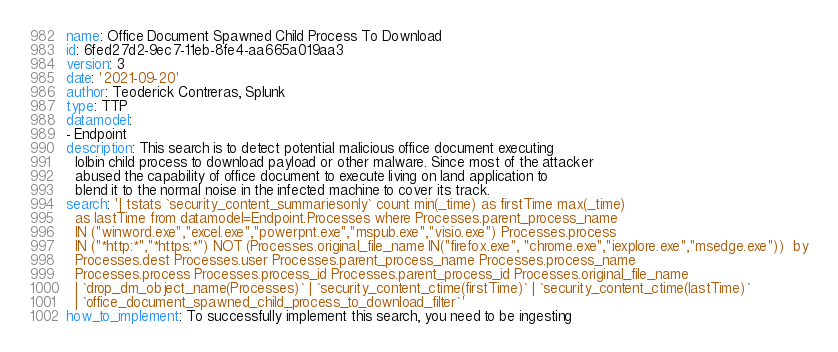Convert code to text. <code><loc_0><loc_0><loc_500><loc_500><_YAML_>name: Office Document Spawned Child Process To Download
id: 6fed27d2-9ec7-11eb-8fe4-aa665a019aa3
version: 3
date: '2021-09-20'
author: Teoderick Contreras, Splunk
type: TTP
datamodel:
- Endpoint
description: This search is to detect potential malicious office document executing
  lolbin child process to download payload or other malware. Since most of the attacker
  abused the capability of office document to execute living on land application to
  blend it to the normal noise in the infected machine to cover its track.
search: '| tstats `security_content_summariesonly` count min(_time) as firstTime max(_time)
  as lastTime from datamodel=Endpoint.Processes where Processes.parent_process_name
  IN ("winword.exe","excel.exe","powerpnt.exe","mspub.exe","visio.exe") Processes.process
  IN ("*http:*","*https:*") NOT (Processes.original_file_name IN("firefox.exe", "chrome.exe","iexplore.exe","msedge.exe"))  by
  Processes.dest Processes.user Processes.parent_process_name Processes.process_name
  Processes.process Processes.process_id Processes.parent_process_id Processes.original_file_name
  | `drop_dm_object_name(Processes)` | `security_content_ctime(firstTime)` | `security_content_ctime(lastTime)`
  | `office_document_spawned_child_process_to_download_filter`'
how_to_implement: To successfully implement this search, you need to be ingesting</code> 